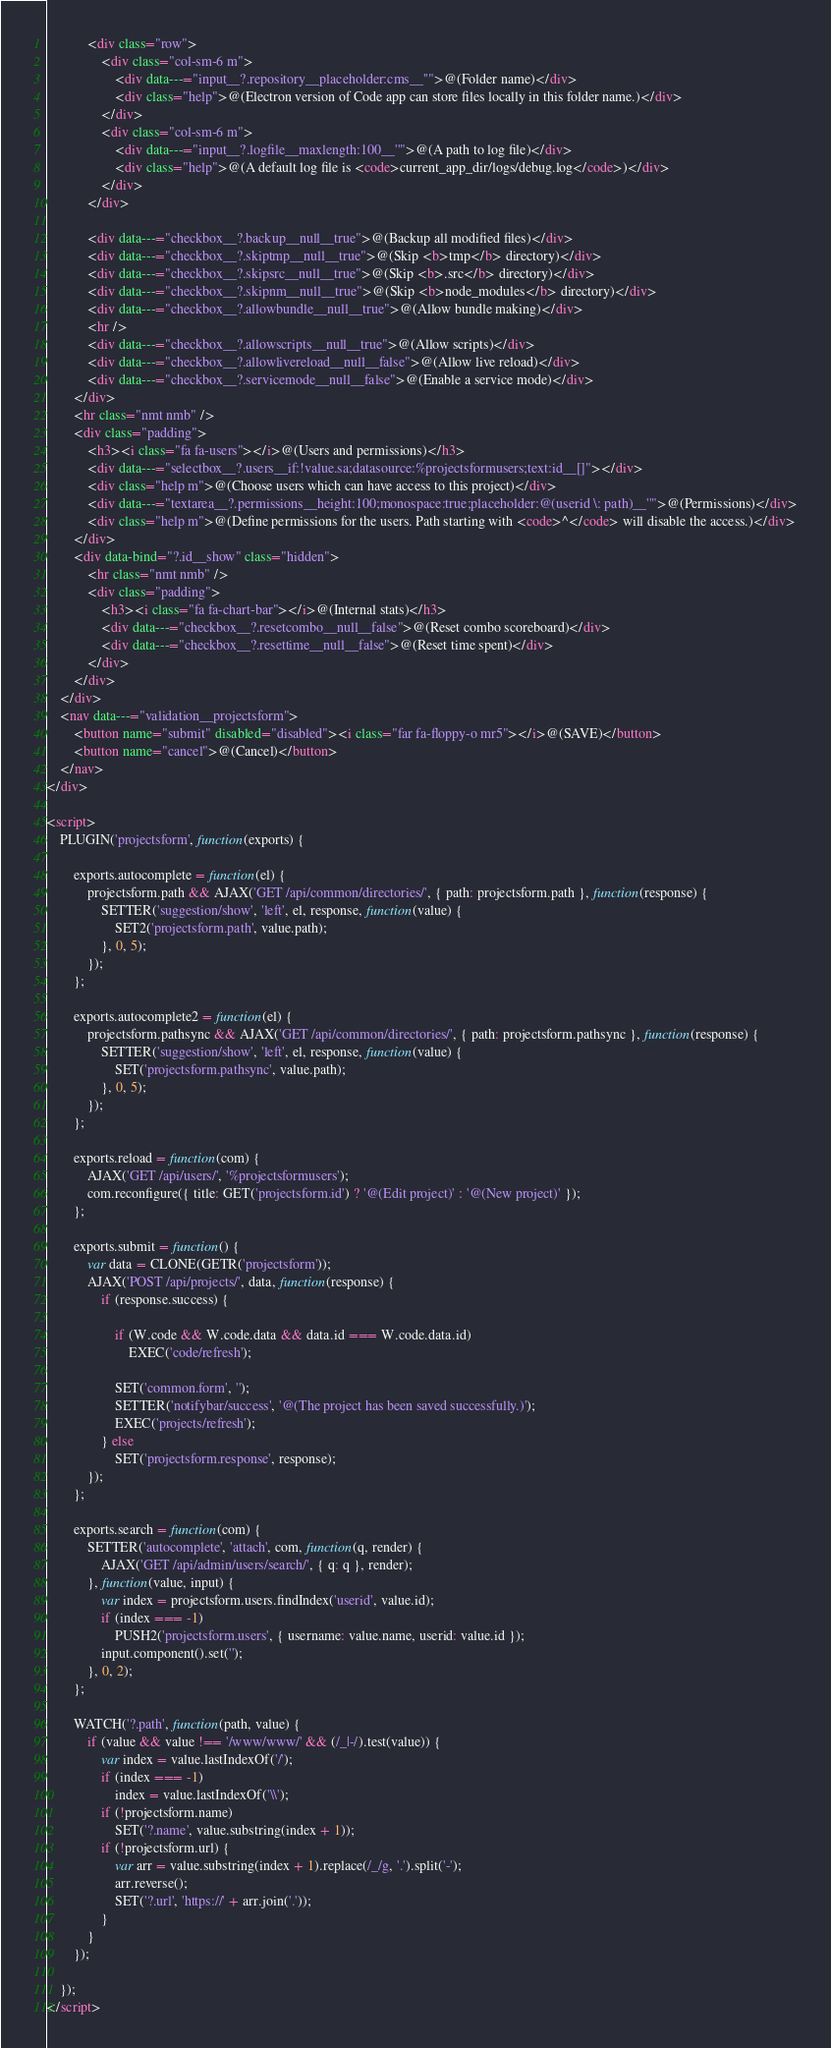<code> <loc_0><loc_0><loc_500><loc_500><_HTML_>			<div class="row">
				<div class="col-sm-6 m">
					<div data---="input__?.repository__placeholder:cms__''">@(Folder name)</div>
					<div class="help">@(Electron version of Code app can store files locally in this folder name.)</div>
				</div>
				<div class="col-sm-6 m">
					<div data---="input__?.logfile__maxlength:100__''">@(A path to log file)</div>
					<div class="help">@(A default log file is <code>current_app_dir/logs/debug.log</code>)</div>
				</div>
			</div>

			<div data---="checkbox__?.backup__null__true">@(Backup all modified files)</div>
			<div data---="checkbox__?.skiptmp__null__true">@(Skip <b>tmp</b> directory)</div>
			<div data---="checkbox__?.skipsrc__null__true">@(Skip <b>.src</b> directory)</div>
			<div data---="checkbox__?.skipnm__null__true">@(Skip <b>node_modules</b> directory)</div>
			<div data---="checkbox__?.allowbundle__null__true">@(Allow bundle making)</div>
			<hr />
			<div data---="checkbox__?.allowscripts__null__true">@(Allow scripts)</div>
			<div data---="checkbox__?.allowlivereload__null__false">@(Allow live reload)</div>
			<div data---="checkbox__?.servicemode__null__false">@(Enable a service mode)</div>
		</div>
		<hr class="nmt nmb" />
		<div class="padding">
			<h3><i class="fa fa-users"></i>@(Users and permissions)</h3>
			<div data---="selectbox__?.users__if:!value.sa;datasource:%projectsformusers;text:id__[]"></div>
			<div class="help m">@(Choose users which can have access to this project)</div>
			<div data---="textarea__?.permissions__height:100;monospace:true;placeholder:@(userid \: path)__''">@(Permissions)</div>
			<div class="help m">@(Define permissions for the users. Path starting with <code>^</code> will disable the access.)</div>
		</div>
		<div data-bind="?.id__show" class="hidden">
			<hr class="nmt nmb" />
			<div class="padding">
				<h3><i class="fa fa-chart-bar"></i>@(Internal stats)</h3>
				<div data---="checkbox__?.resetcombo__null__false">@(Reset combo scoreboard)</div>
				<div data---="checkbox__?.resettime__null__false">@(Reset time spent)</div>
			</div>
		</div>
	</div>
	<nav data---="validation__projectsform">
		<button name="submit" disabled="disabled"><i class="far fa-floppy-o mr5"></i>@(SAVE)</button>
		<button name="cancel">@(Cancel)</button>
	</nav>
</div>

<script>
	PLUGIN('projectsform', function(exports) {

		exports.autocomplete = function(el) {
			projectsform.path && AJAX('GET /api/common/directories/', { path: projectsform.path }, function(response) {
				SETTER('suggestion/show', 'left', el, response, function(value) {
					SET2('projectsform.path', value.path);
				}, 0, 5);
			});
		};

		exports.autocomplete2 = function(el) {
			projectsform.pathsync && AJAX('GET /api/common/directories/', { path: projectsform.pathsync }, function(response) {
				SETTER('suggestion/show', 'left', el, response, function(value) {
					SET('projectsform.pathsync', value.path);
				}, 0, 5);
			});
		};

		exports.reload = function(com) {
			AJAX('GET /api/users/', '%projectsformusers');
			com.reconfigure({ title: GET('projectsform.id') ? '@(Edit project)' : '@(New project)' });
		};

		exports.submit = function() {
			var data = CLONE(GETR('projectsform'));
			AJAX('POST /api/projects/', data, function(response) {
				if (response.success) {

					if (W.code && W.code.data && data.id === W.code.data.id)
						EXEC('code/refresh');

					SET('common.form', '');
					SETTER('notifybar/success', '@(The project has been saved successfully.)');
					EXEC('projects/refresh');
				} else
					SET('projectsform.response', response);
			});
		};

		exports.search = function(com) {
			SETTER('autocomplete', 'attach', com, function(q, render) {
				AJAX('GET /api/admin/users/search/', { q: q }, render);
			}, function(value, input) {
				var index = projectsform.users.findIndex('userid', value.id);
				if (index === -1)
					PUSH2('projectsform.users', { username: value.name, userid: value.id });
				input.component().set('');
			}, 0, 2);
		};

		WATCH('?.path', function(path, value) {
			if (value && value !== '/www/www/' && (/_|-/).test(value)) {
				var index = value.lastIndexOf('/');
				if (index === -1)
					index = value.lastIndexOf('\\');
				if (!projectsform.name)
					SET('?.name', value.substring(index + 1));
				if (!projectsform.url) {
					var arr = value.substring(index + 1).replace(/_/g, '.').split('-');
					arr.reverse();
					SET('?.url', 'https://' + arr.join('.'));
				}
			}
		});

	});
</script></code> 